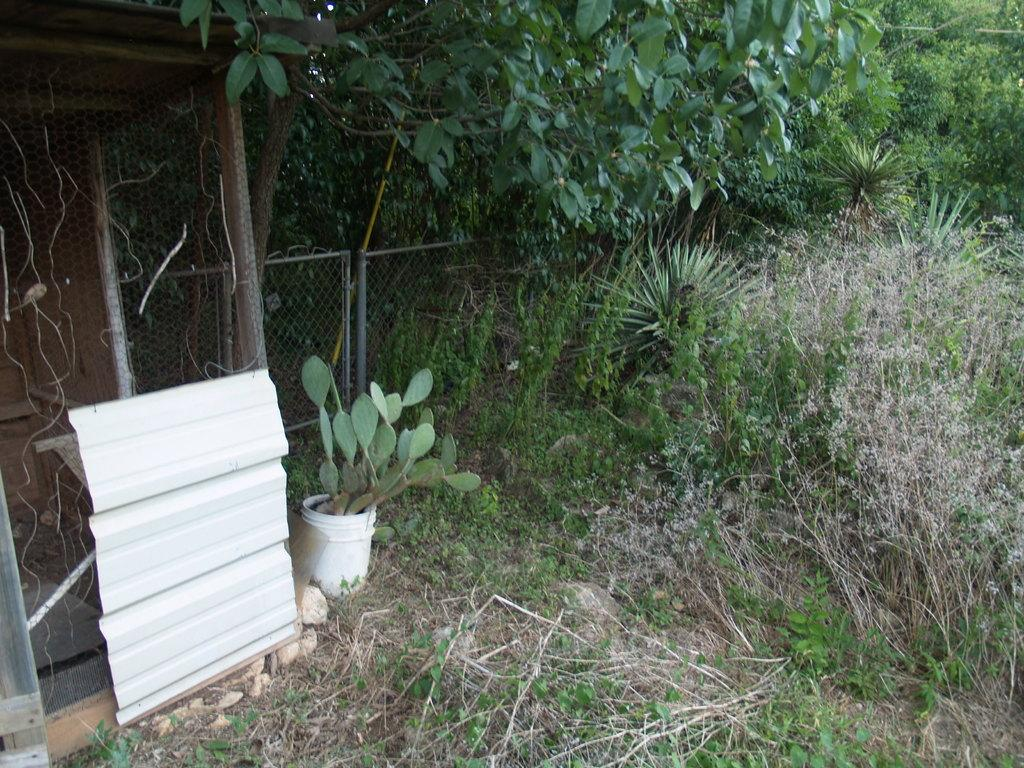What type of vegetation can be seen in the image? There is grass and trees in the image. What structure is present in the image? There is a fence in the image. What is the cactus plant placed in? The cactus plant is in a bucket in the image. What additional object can be seen in the image? There is a white sheet in the image. Can you see the elbow of the person holding the cactus plant in the image? There is no person holding the cactus plant in the image, so there is no elbow to be seen. 